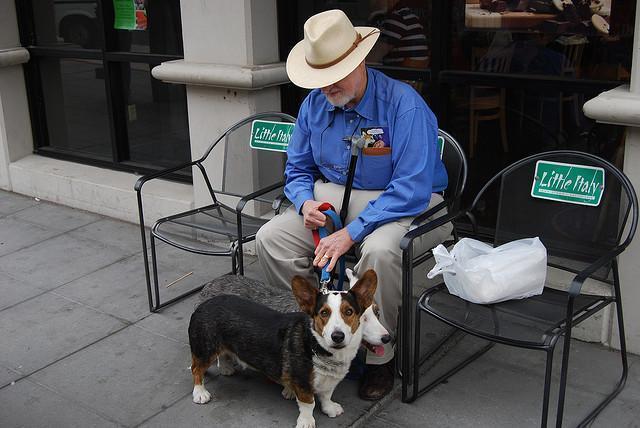How many dogs are there?
Give a very brief answer. 2. How many people can you see?
Give a very brief answer. 2. How many chairs are there?
Give a very brief answer. 2. How many dogs are visible?
Give a very brief answer. 2. 